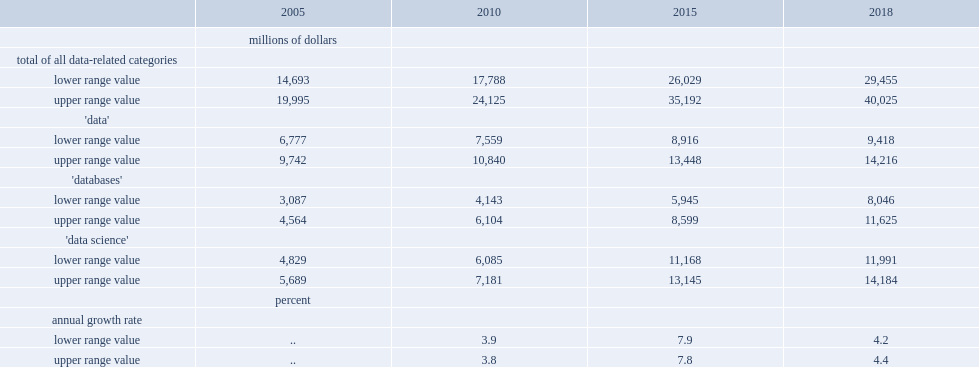What are the lower and upper range value of total investment at current prices respectively? 29455.0 40025.0. 